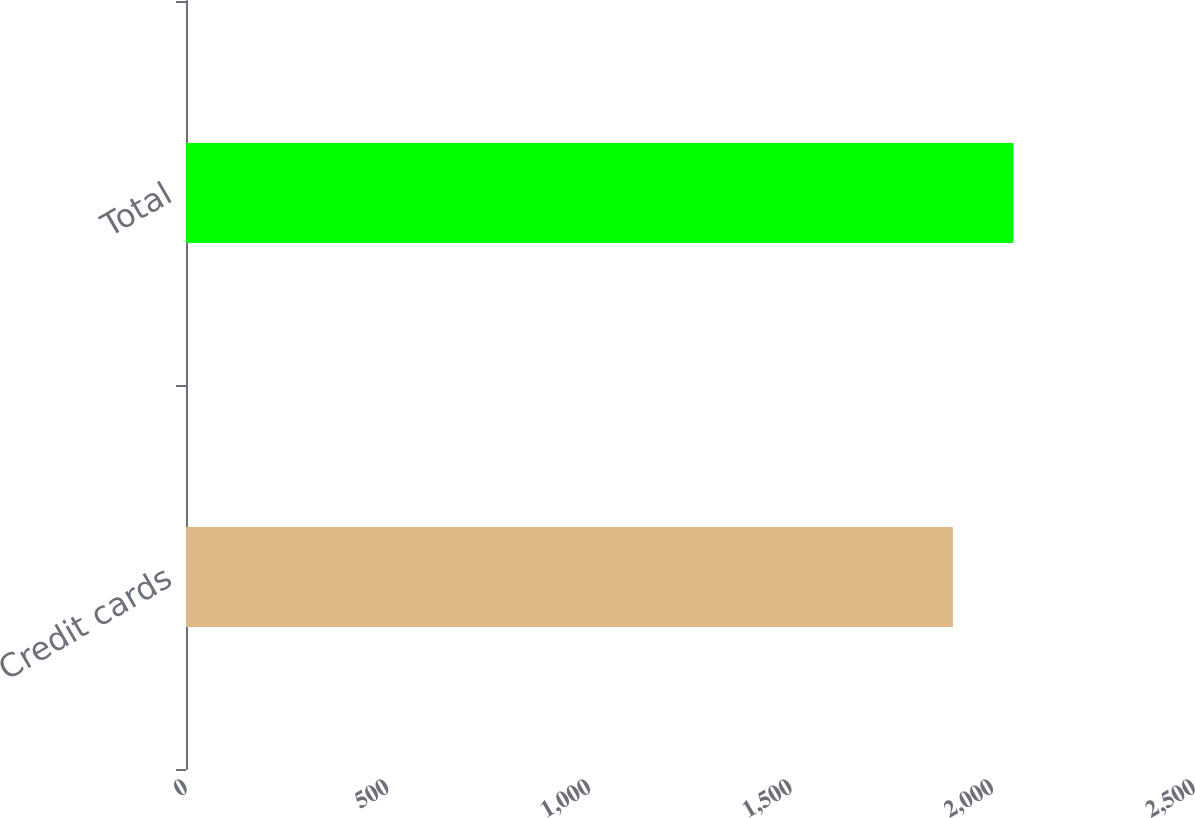Convert chart to OTSL. <chart><loc_0><loc_0><loc_500><loc_500><bar_chart><fcel>Credit cards<fcel>Total<nl><fcel>1902<fcel>2052<nl></chart> 